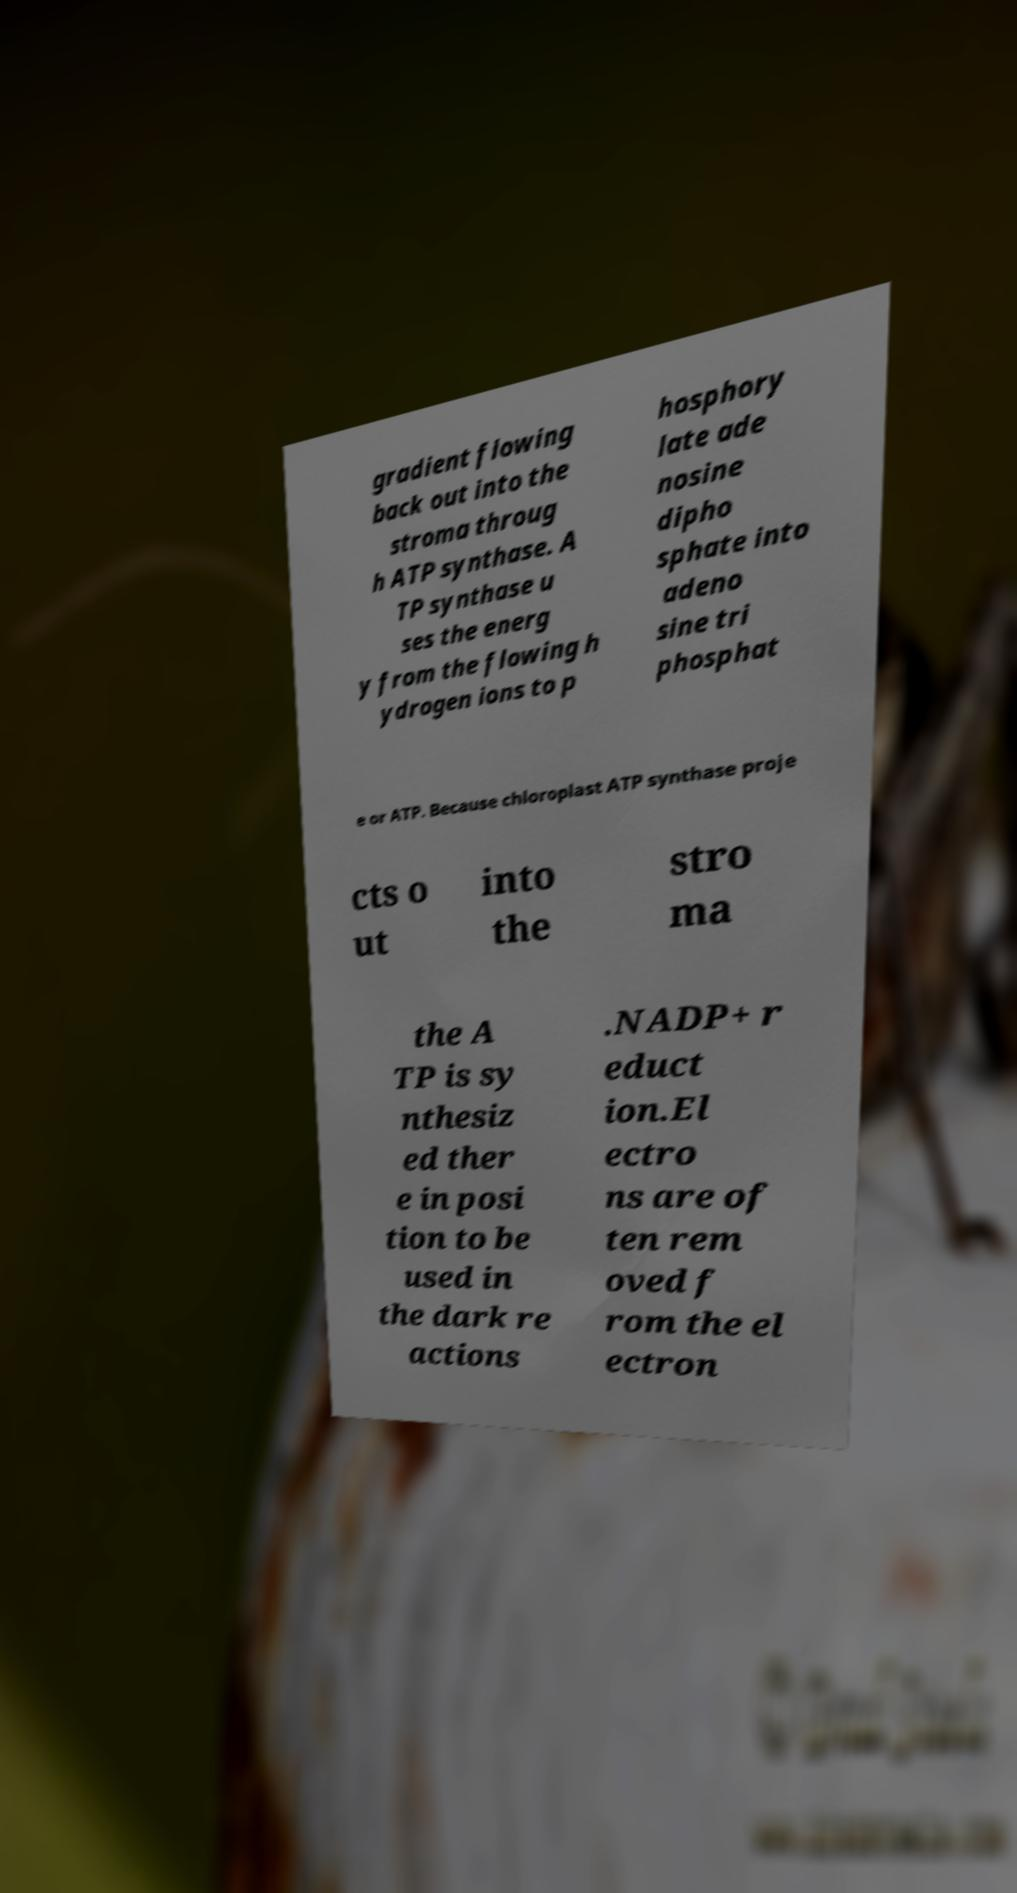What messages or text are displayed in this image? I need them in a readable, typed format. gradient flowing back out into the stroma throug h ATP synthase. A TP synthase u ses the energ y from the flowing h ydrogen ions to p hosphory late ade nosine dipho sphate into adeno sine tri phosphat e or ATP. Because chloroplast ATP synthase proje cts o ut into the stro ma the A TP is sy nthesiz ed ther e in posi tion to be used in the dark re actions .NADP+ r educt ion.El ectro ns are of ten rem oved f rom the el ectron 